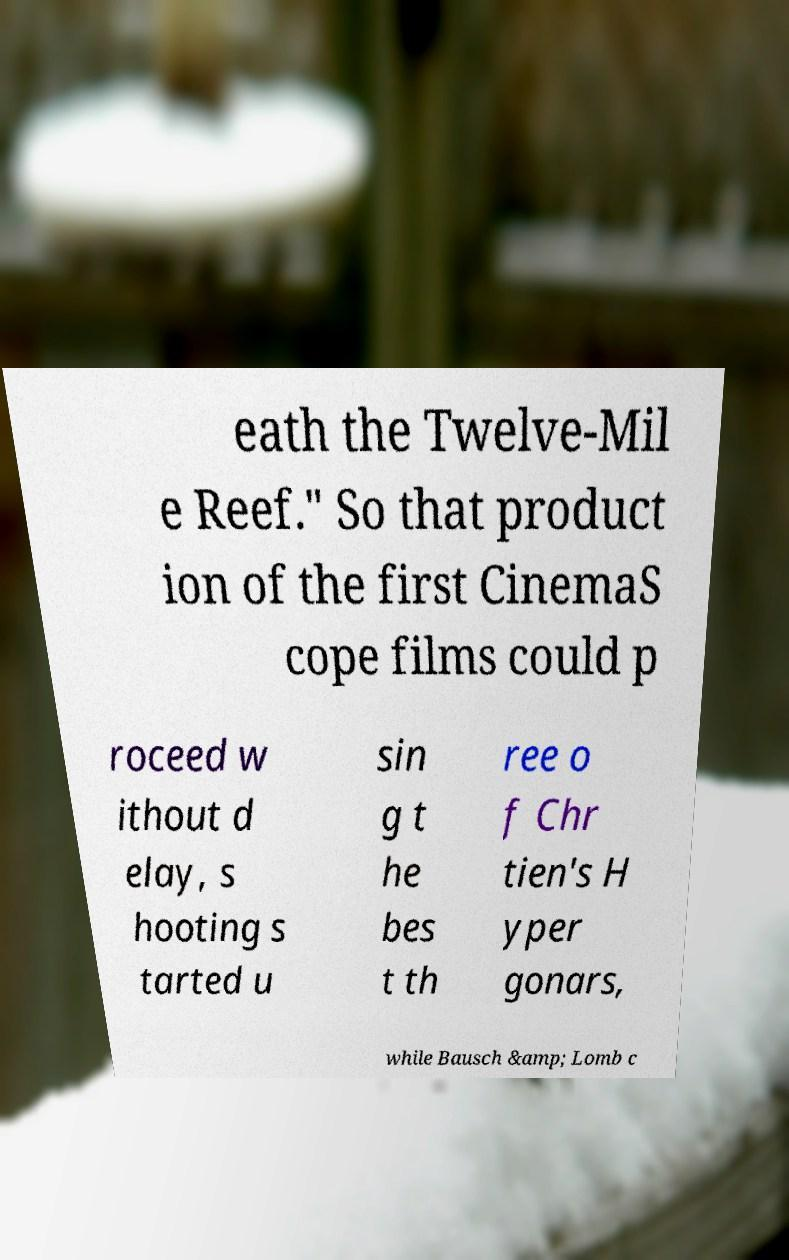There's text embedded in this image that I need extracted. Can you transcribe it verbatim? eath the Twelve-Mil e Reef." So that product ion of the first CinemaS cope films could p roceed w ithout d elay, s hooting s tarted u sin g t he bes t th ree o f Chr tien's H yper gonars, while Bausch &amp; Lomb c 